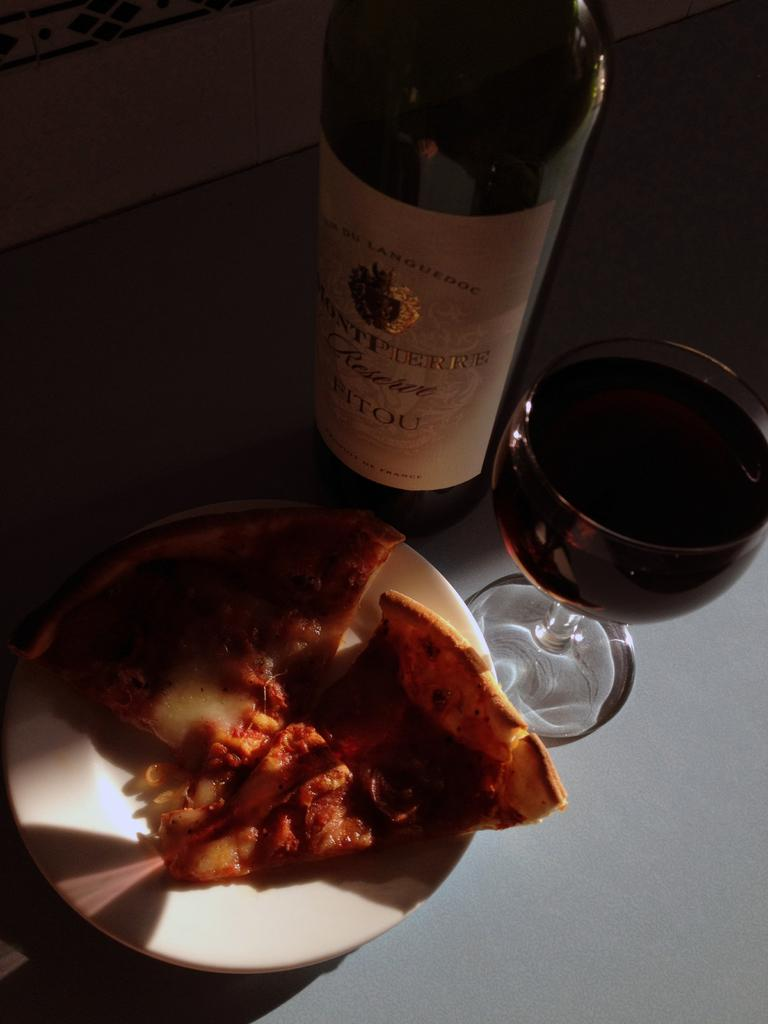<image>
Summarize the visual content of the image. A glass of Montpierre reserve wine sits next to its bottle and some food. 